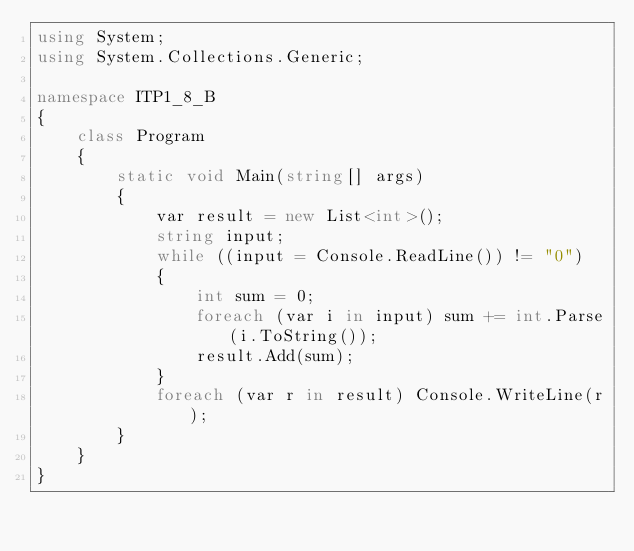<code> <loc_0><loc_0><loc_500><loc_500><_C#_>using System;
using System.Collections.Generic;

namespace ITP1_8_B
{
    class Program
    {
        static void Main(string[] args)
        {
            var result = new List<int>();
            string input;
            while ((input = Console.ReadLine()) != "0")
            {
                int sum = 0;
                foreach (var i in input) sum += int.Parse(i.ToString());                 
                result.Add(sum);
            }
            foreach (var r in result) Console.WriteLine(r);               
        }
    }
}</code> 